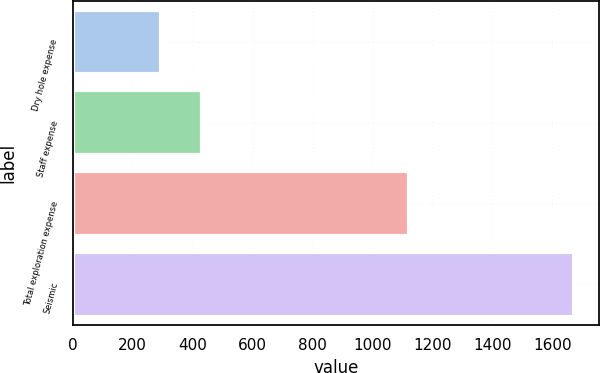Convert chart. <chart><loc_0><loc_0><loc_500><loc_500><bar_chart><fcel>Dry hole expense<fcel>Staff expense<fcel>Total exploration expense<fcel>Seismic<nl><fcel>293<fcel>430.8<fcel>1123<fcel>1671<nl></chart> 